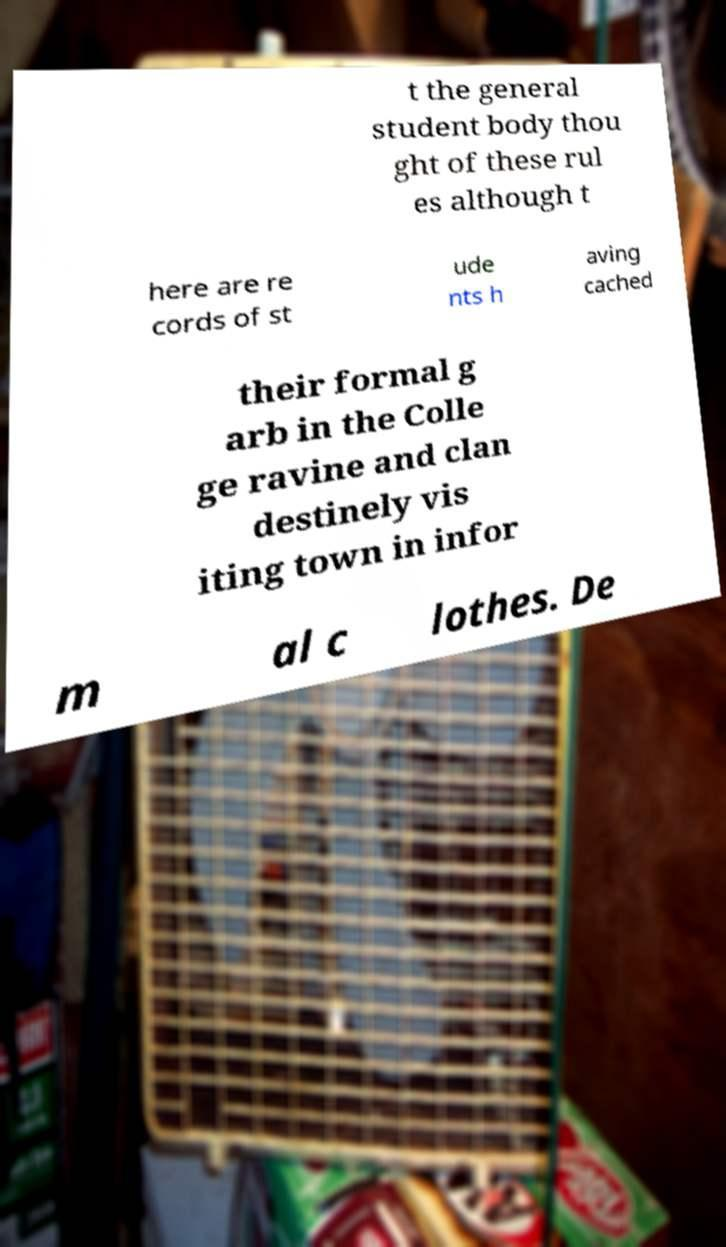For documentation purposes, I need the text within this image transcribed. Could you provide that? t the general student body thou ght of these rul es although t here are re cords of st ude nts h aving cached their formal g arb in the Colle ge ravine and clan destinely vis iting town in infor m al c lothes. De 